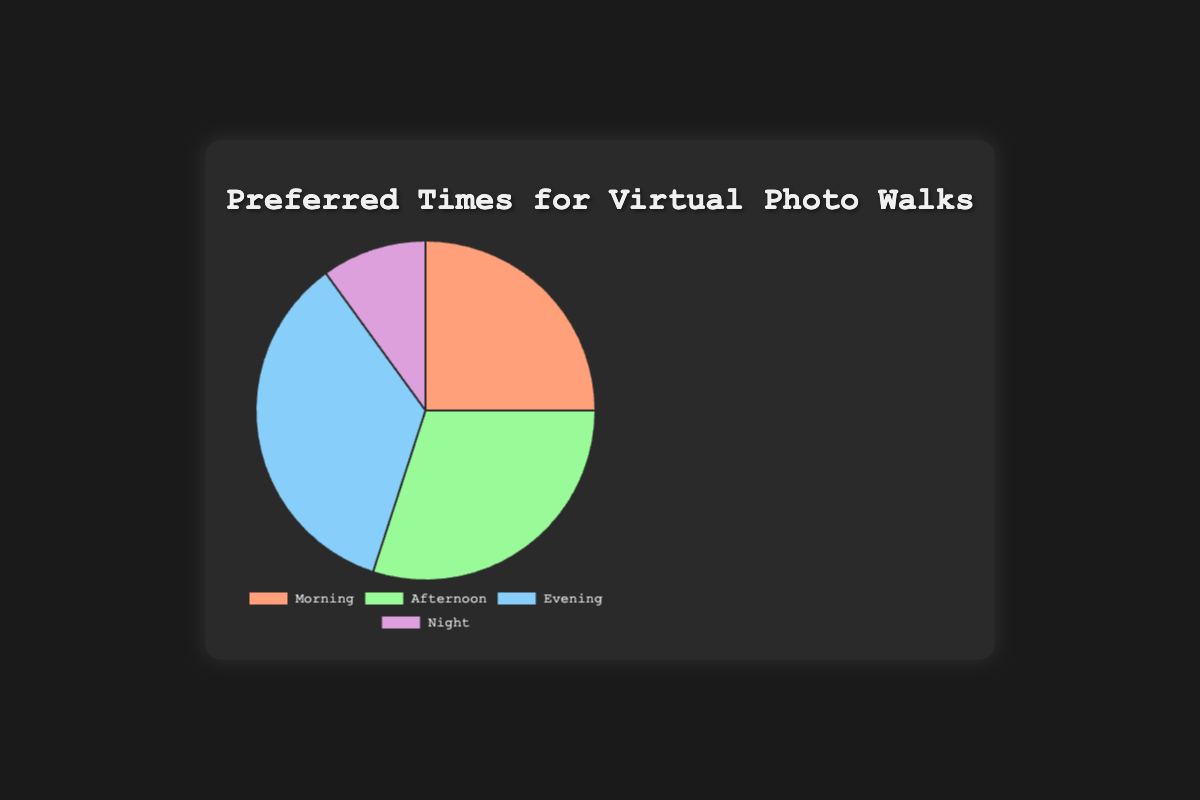What's the most preferred time of day for virtual photo walks? To determine the most preferred time of day, look for the segment with the largest percentage. That segment is 'Evening' with 35%.
Answer: Evening Which time of day has the lowest preference for virtual photo walks? To find the time of day with the lowest preference, look for the segment with the smallest percentage. That segment is 'Night' with 10%.
Answer: Night How much more preferred is the Afternoon compared to the Morning? Subtract the percentage of Morning from the percentage of Afternoon: 30% - 25% = 5%.
Answer: 5% What is the combined percentage preference for Morning and Night walks? Add the percentages for Morning and Night: 25% + 10% = 35%.
Answer: 35% Which two times of day have a combined preference of 65%? Look for two segments whose combined percentages add up to 65%. Morning and Afternoon together have 25% + 30% = 55%, and Afternoon and Evening together have 30% + 35% = 65%.
Answer: Afternoon and Evening Is Evening more than twice as preferred as Night? To check if Evening is more than twice as preferred as Night, compare 35% to double the percentage of Night: 35% > 2*10%. Since 35% > 20%, Evening is indeed more than twice as preferred.
Answer: Yes What is the difference in preference between the least and most preferred times of day? Subtract the percentage of the least preferred time (Night) from the percentage of the most preferred time (Evening): 35% - 10% = 25%.
Answer: 25% What percentage of the preferred times is not in the Morning or Afternoon? Subtract the combined percentage of Morning and Afternoon from 100%: 100% - (25% + 30%) = 100% - 55% = 45%.
Answer: 45% If we merge Morning and Afternoon into a single category, what percentage will that new category have? Add the percentages of Morning and Afternoon together: 25% + 30% = 55%.
Answer: 55% 